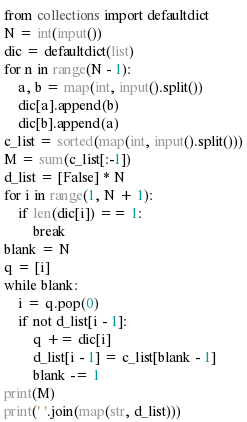Convert code to text. <code><loc_0><loc_0><loc_500><loc_500><_Python_>from collections import defaultdict
N = int(input())
dic = defaultdict(list)
for n in range(N - 1):
    a, b = map(int, input().split())
    dic[a].append(b)
    dic[b].append(a)
c_list = sorted(map(int, input().split()))
M = sum(c_list[:-1])
d_list = [False] * N
for i in range(1, N + 1):
    if len(dic[i]) == 1:
        break
blank = N
q = [i]
while blank:
    i = q.pop(0)
    if not d_list[i - 1]:
        q += dic[i]
        d_list[i - 1] = c_list[blank - 1]
        blank -= 1
print(M)
print(' '.join(map(str, d_list)))</code> 